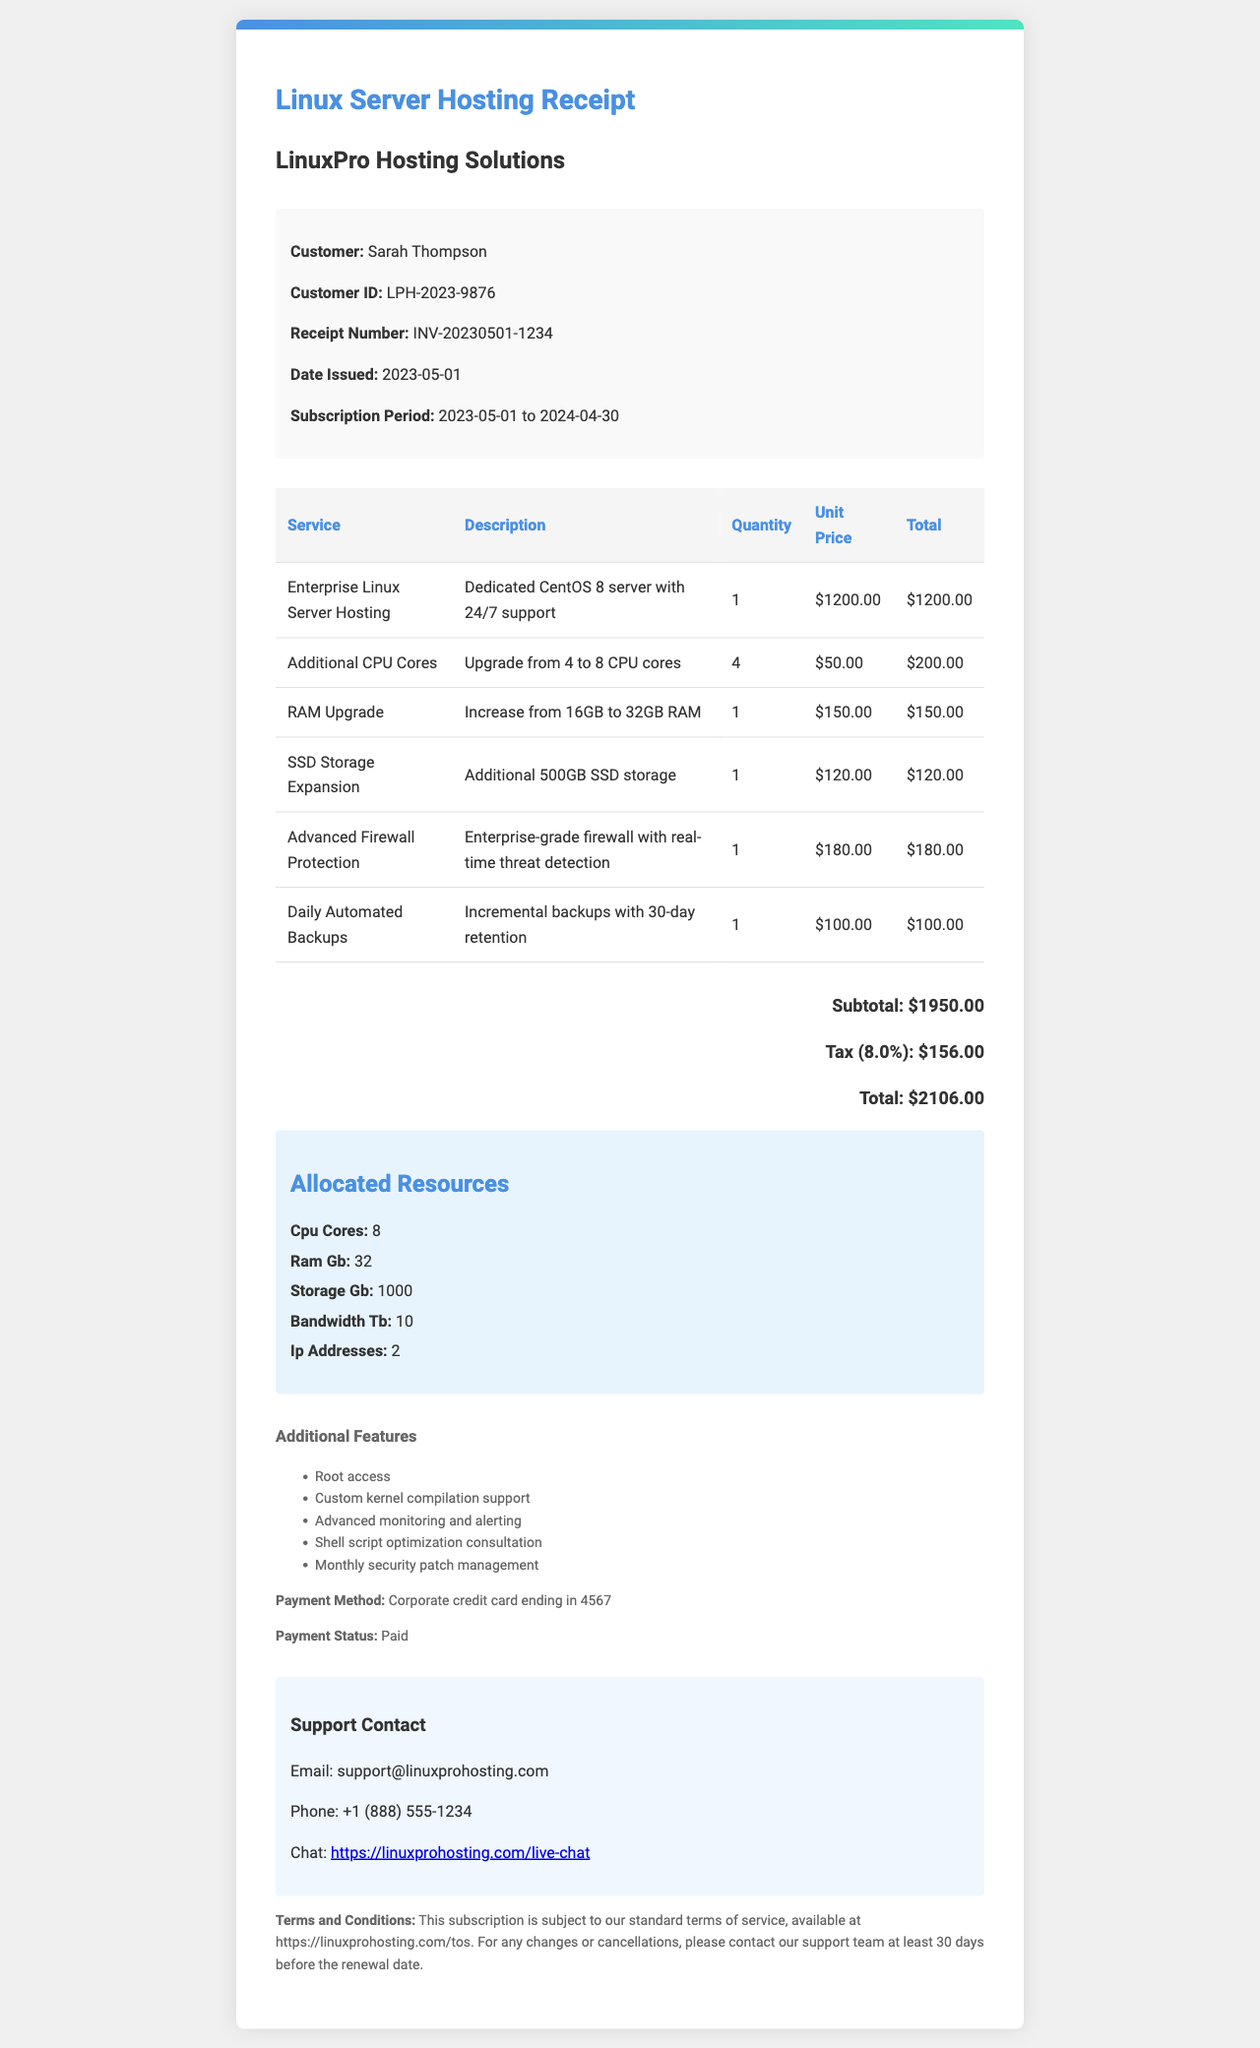what is the company name? The company name is listed at the top of the receipt document.
Answer: LinuxPro Hosting Solutions who is the customer? The customer's name appears in the customer information section of the document.
Answer: Sarah Thompson what is the receipt number? The receipt number is specified near the top of the document, under customer information.
Answer: INV-20230501-1234 what is the total amount? The total amount is calculated from the subtotal and tax and is stated at the bottom of the receipt.
Answer: 2106.00 how many CPU cores are allocated? The number of allocated CPU cores is listed in the allocated resources section of the document.
Answer: 8 what is the unit price of the RAM upgrade? The unit price of the RAM upgrade is listed in the services table in the document.
Answer: 150.00 how many additional features are listed? The number of additional features can be counted in the additional features section of the document.
Answer: 5 when does the subscription period end? The end date of the subscription period is clearly mentioned in the subscription period detail.
Answer: 2024-04-30 what payment method was used? The payment method is specified in the additional information section of the receipt.
Answer: Corporate credit card ending in 4567 